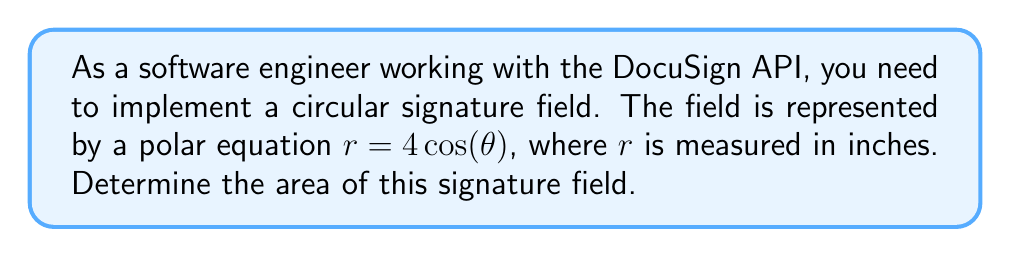Can you answer this question? To solve this problem, we'll follow these steps:

1) The polar equation $r = 4\cos(\theta)$ represents a circle. This can be verified by converting it to Cartesian coordinates, but we don't need to do that for this problem.

2) The formula for the area of a region in polar coordinates is:

   $$A = \frac{1}{2}\int_a^b r^2(\theta) d\theta$$

   where $a$ and $b$ are the starting and ending angles of the region.

3) For a full circle, we integrate from 0 to $2\pi$:

   $$A = \frac{1}{2}\int_0^{2\pi} (4\cos(\theta))^2 d\theta$$

4) Simplify the integrand:

   $$A = \frac{1}{2}\int_0^{2\pi} 16\cos^2(\theta) d\theta$$

5) Use the trigonometric identity $\cos^2(\theta) = \frac{1 + \cos(2\theta)}{2}$:

   $$A = \frac{1}{2}\int_0^{2\pi} 16 \cdot \frac{1 + \cos(2\theta)}{2} d\theta$$
   $$A = 4\int_0^{2\pi} (1 + \cos(2\theta)) d\theta$$

6) Integrate:

   $$A = 4[\theta + \frac{1}{2}\sin(2\theta)]_0^{2\pi}$$

7) Evaluate the integral:

   $$A = 4[(2\pi + 0) - (0 + 0)] = 8\pi$$

8) The area is in square inches, as $r$ was measured in inches.
Answer: The area of the circular signature field is $8\pi$ square inches. 